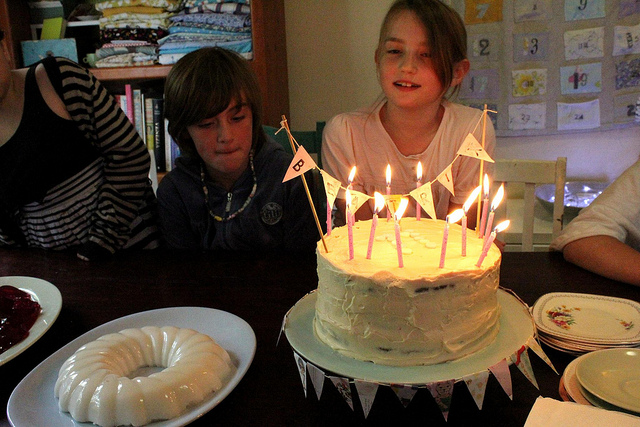How many people are in the picture? There appear to be at least four individuals gathered around a cake, suggesting that they might be celebrating a special occasion like a birthday. 